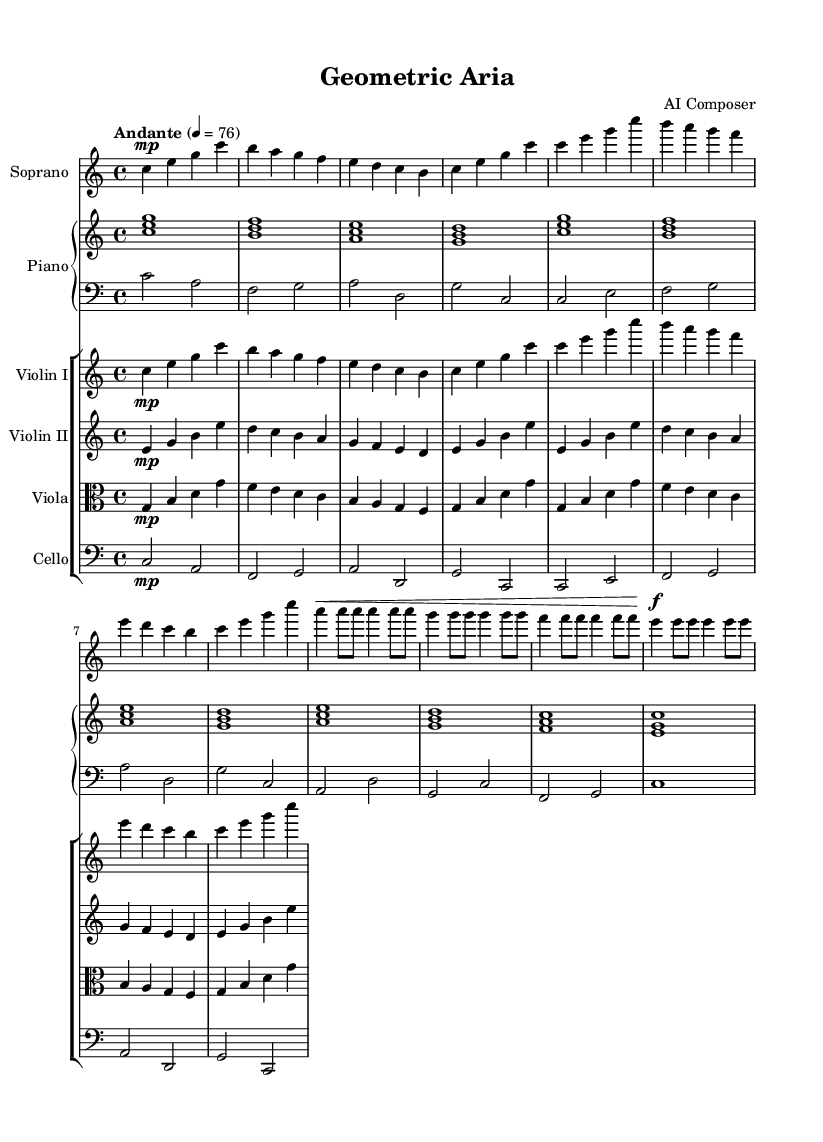What is the key signature of this music? The key signature is C major, which has no sharps or flats.
Answer: C major What is the time signature of this score? The time signature is indicated as 4/4, meaning there are four beats in a measure.
Answer: 4/4 What is the tempo marking in the sheet music? The tempo marking indicates the piece should be played at a speed of 76 beats per minute and is described as "Andante."
Answer: Andante How many measures are there in the introduction section? The introduction consists of 4 measures based on the notated music.
Answer: 4 Which instrument has a bass clef staff? The piano's left hand (pianoLH) is notated on a staff with a bass clef.
Answer: Piano Which voice part has a dynamic marking of "mp"? The soprano voice part features a marking of "mp," which stands for mezzo-piano, indicating a moderate soft volume.
Answer: Soprano What pattern is repeated in the verse section? The same melodic sequence from the introduction is replicated in the verse section.
Answer: Repetition 